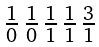Convert formula to latex. <formula><loc_0><loc_0><loc_500><loc_500>\begin{smallmatrix} 1 & 1 & 1 & 1 & 3 \\ \overline { 0 } & \overline { 0 } & \overline { 1 } & \overline { 1 } & \overline { 1 } \end{smallmatrix}</formula> 